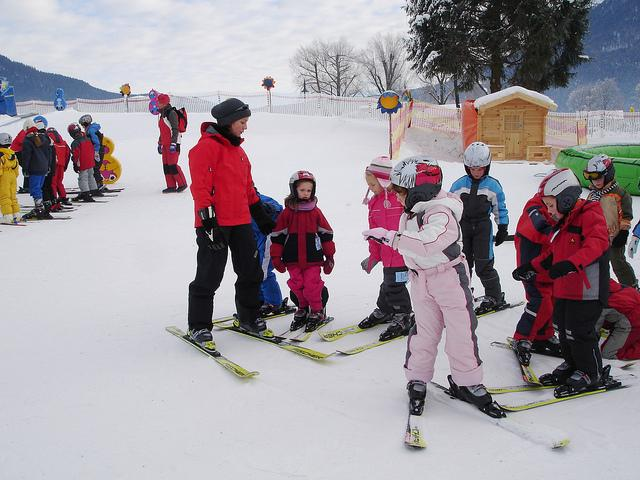Different parabolic shapes are found in?

Choices:
A) poles
B) surfs
C) snowblades
D) kites snowblades 